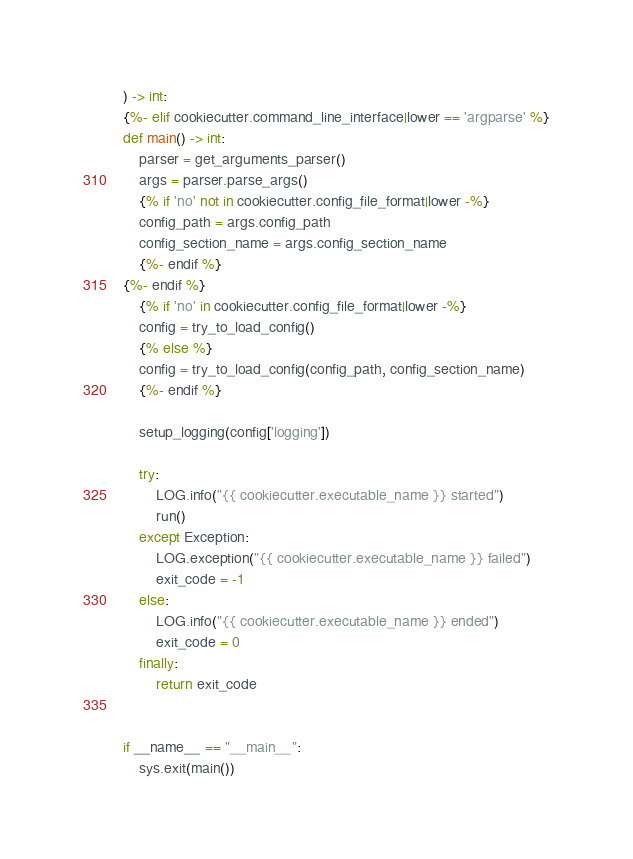<code> <loc_0><loc_0><loc_500><loc_500><_Python_>) -> int:
{%- elif cookiecutter.command_line_interface|lower == 'argparse' %}
def main() -> int:
    parser = get_arguments_parser()
    args = parser.parse_args()
    {% if 'no' not in cookiecutter.config_file_format|lower -%}
    config_path = args.config_path
    config_section_name = args.config_section_name
    {%- endif %}
{%- endif %}
    {% if 'no' in cookiecutter.config_file_format|lower -%}
    config = try_to_load_config()
    {% else %}
    config = try_to_load_config(config_path, config_section_name)
    {%- endif %}

    setup_logging(config['logging'])

    try:
        LOG.info("{{ cookiecutter.executable_name }} started")
        run()
    except Exception:
        LOG.exception("{{ cookiecutter.executable_name }} failed")
        exit_code = -1
    else:
        LOG.info("{{ cookiecutter.executable_name }} ended")
        exit_code = 0
    finally:
        return exit_code


if __name__ == "__main__":
    sys.exit(main())
</code> 